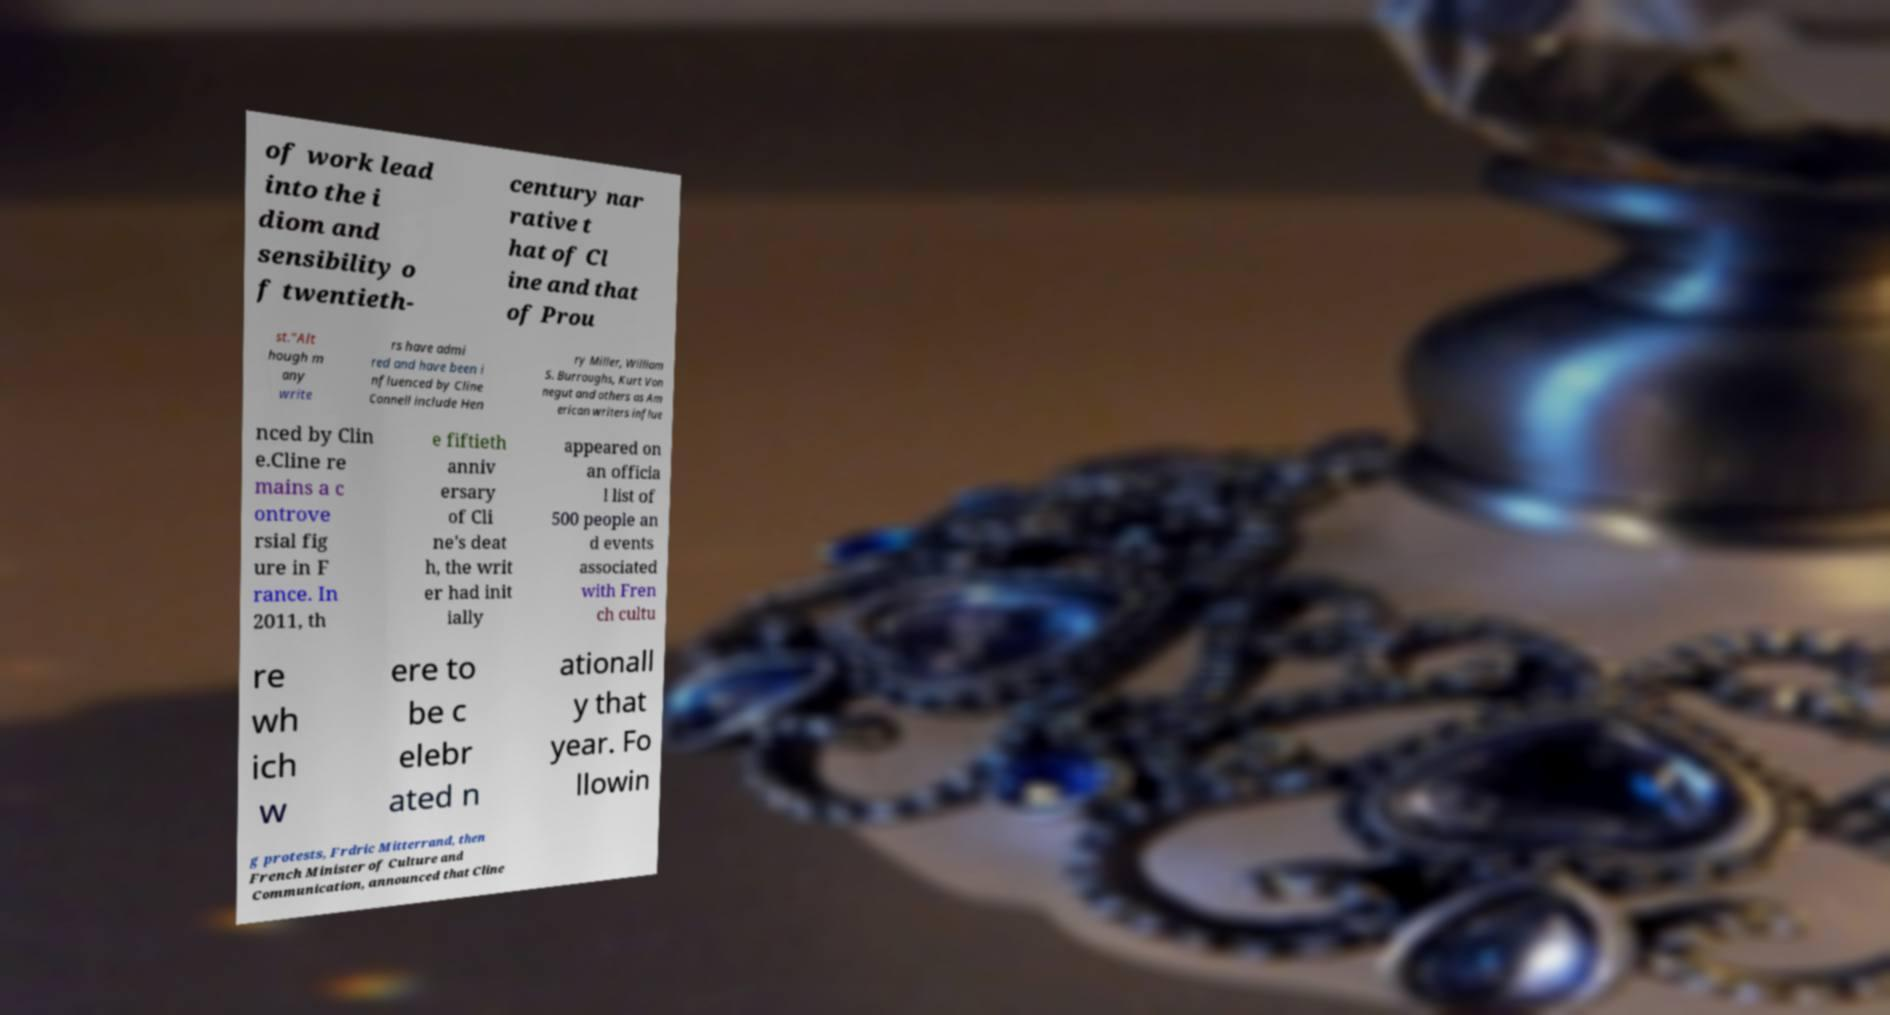For documentation purposes, I need the text within this image transcribed. Could you provide that? of work lead into the i diom and sensibility o f twentieth- century nar rative t hat of Cl ine and that of Prou st."Alt hough m any write rs have admi red and have been i nfluenced by Cline Connell include Hen ry Miller, William S. Burroughs, Kurt Von negut and others as Am erican writers influe nced by Clin e.Cline re mains a c ontrove rsial fig ure in F rance. In 2011, th e fiftieth anniv ersary of Cli ne's deat h, the writ er had init ially appeared on an officia l list of 500 people an d events associated with Fren ch cultu re wh ich w ere to be c elebr ated n ationall y that year. Fo llowin g protests, Frdric Mitterrand, then French Minister of Culture and Communication, announced that Cline 